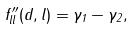Convert formula to latex. <formula><loc_0><loc_0><loc_500><loc_500>f ^ { \prime \prime } _ { l l } ( d , l ) = \gamma _ { 1 } - \gamma _ { 2 } ,</formula> 